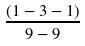Convert formula to latex. <formula><loc_0><loc_0><loc_500><loc_500>\frac { ( 1 - 3 - 1 ) } { 9 - 9 }</formula> 